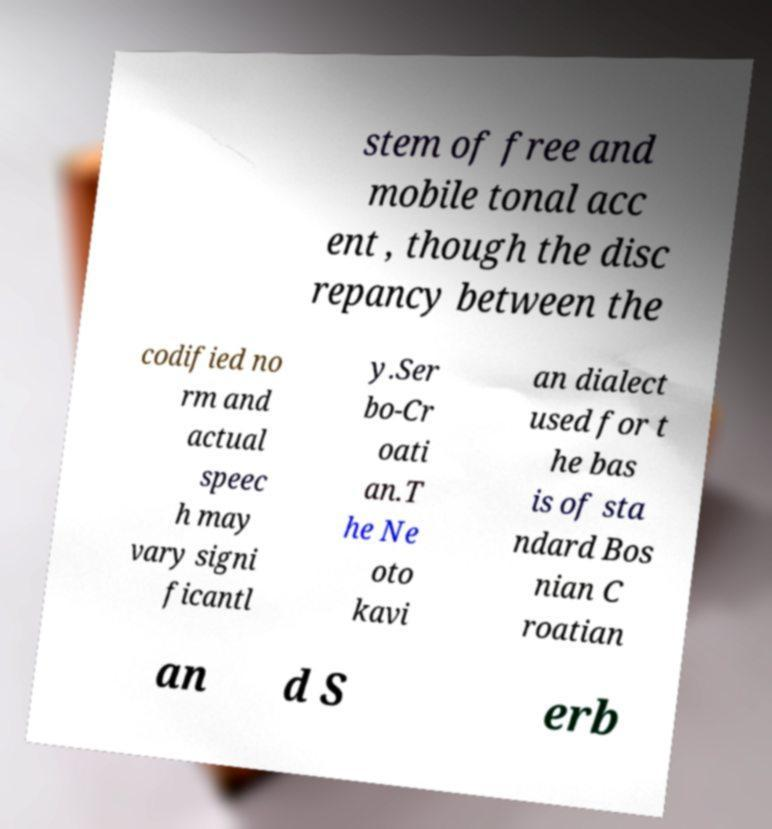For documentation purposes, I need the text within this image transcribed. Could you provide that? stem of free and mobile tonal acc ent , though the disc repancy between the codified no rm and actual speec h may vary signi ficantl y.Ser bo-Cr oati an.T he Ne oto kavi an dialect used for t he bas is of sta ndard Bos nian C roatian an d S erb 